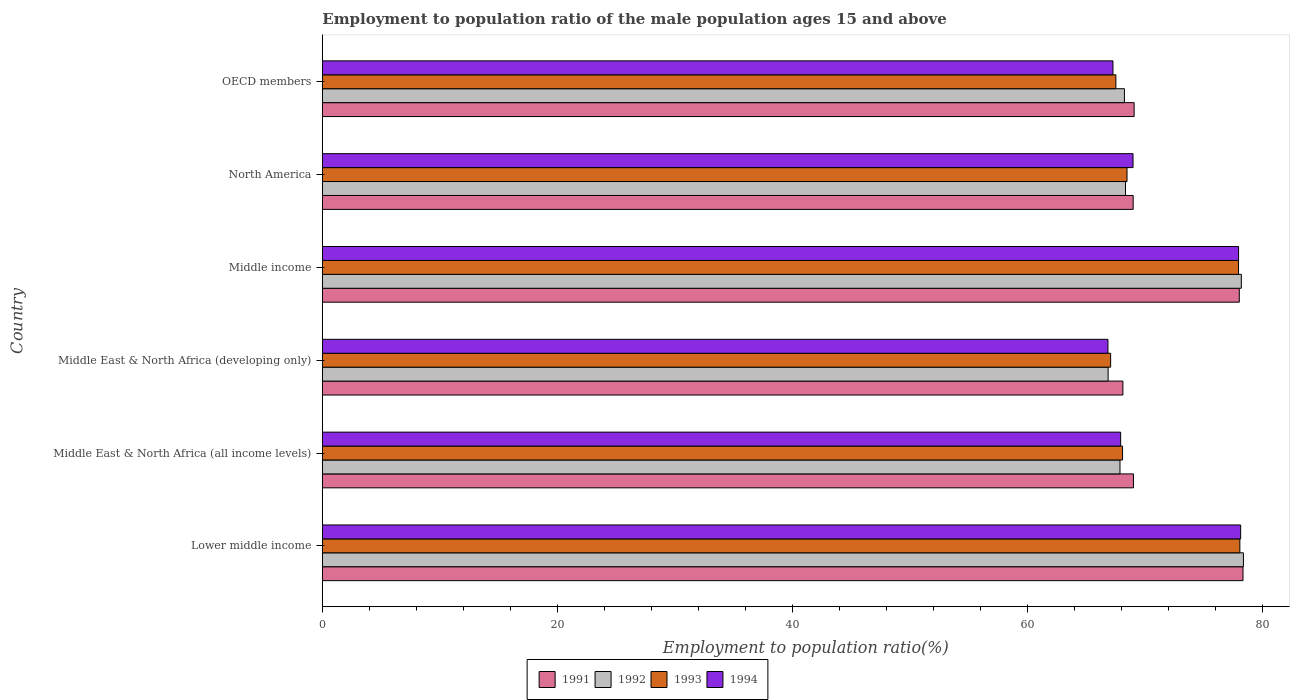How many groups of bars are there?
Offer a very short reply. 6. Are the number of bars per tick equal to the number of legend labels?
Your answer should be very brief. Yes. How many bars are there on the 3rd tick from the top?
Provide a succinct answer. 4. What is the label of the 6th group of bars from the top?
Keep it short and to the point. Lower middle income. In how many cases, is the number of bars for a given country not equal to the number of legend labels?
Make the answer very short. 0. What is the employment to population ratio in 1993 in Middle East & North Africa (developing only)?
Keep it short and to the point. 67.05. Across all countries, what is the maximum employment to population ratio in 1991?
Offer a terse response. 78.3. Across all countries, what is the minimum employment to population ratio in 1992?
Make the answer very short. 66.83. In which country was the employment to population ratio in 1993 maximum?
Make the answer very short. Lower middle income. In which country was the employment to population ratio in 1993 minimum?
Your answer should be very brief. Middle East & North Africa (developing only). What is the total employment to population ratio in 1992 in the graph?
Provide a succinct answer. 427.71. What is the difference between the employment to population ratio in 1993 in Middle East & North Africa (all income levels) and that in Middle income?
Ensure brevity in your answer.  -9.87. What is the difference between the employment to population ratio in 1994 in Middle income and the employment to population ratio in 1992 in North America?
Provide a succinct answer. 9.62. What is the average employment to population ratio in 1992 per country?
Your response must be concise. 71.28. What is the difference between the employment to population ratio in 1992 and employment to population ratio in 1993 in Middle income?
Keep it short and to the point. 0.24. In how many countries, is the employment to population ratio in 1994 greater than 68 %?
Your answer should be compact. 3. What is the ratio of the employment to population ratio in 1991 in Middle income to that in OECD members?
Keep it short and to the point. 1.13. What is the difference between the highest and the second highest employment to population ratio in 1992?
Provide a short and direct response. 0.18. What is the difference between the highest and the lowest employment to population ratio in 1992?
Make the answer very short. 11.51. In how many countries, is the employment to population ratio in 1992 greater than the average employment to population ratio in 1992 taken over all countries?
Your answer should be compact. 2. Is the sum of the employment to population ratio in 1993 in Middle income and North America greater than the maximum employment to population ratio in 1991 across all countries?
Give a very brief answer. Yes. Is it the case that in every country, the sum of the employment to population ratio in 1994 and employment to population ratio in 1992 is greater than the sum of employment to population ratio in 1993 and employment to population ratio in 1991?
Offer a terse response. No. What does the 4th bar from the bottom in Middle East & North Africa (all income levels) represents?
Your answer should be very brief. 1994. Is it the case that in every country, the sum of the employment to population ratio in 1994 and employment to population ratio in 1991 is greater than the employment to population ratio in 1993?
Offer a terse response. Yes. How many bars are there?
Your answer should be very brief. 24. Are all the bars in the graph horizontal?
Offer a terse response. Yes. How many countries are there in the graph?
Provide a short and direct response. 6. What is the difference between two consecutive major ticks on the X-axis?
Give a very brief answer. 20. Does the graph contain any zero values?
Offer a very short reply. No. Does the graph contain grids?
Offer a terse response. No. Where does the legend appear in the graph?
Offer a terse response. Bottom center. How are the legend labels stacked?
Ensure brevity in your answer.  Horizontal. What is the title of the graph?
Offer a very short reply. Employment to population ratio of the male population ages 15 and above. What is the label or title of the X-axis?
Provide a succinct answer. Employment to population ratio(%). What is the Employment to population ratio(%) of 1991 in Lower middle income?
Make the answer very short. 78.3. What is the Employment to population ratio(%) of 1992 in Lower middle income?
Offer a very short reply. 78.34. What is the Employment to population ratio(%) of 1993 in Lower middle income?
Make the answer very short. 78.04. What is the Employment to population ratio(%) of 1994 in Lower middle income?
Make the answer very short. 78.11. What is the Employment to population ratio(%) of 1991 in Middle East & North Africa (all income levels)?
Your answer should be very brief. 68.99. What is the Employment to population ratio(%) of 1992 in Middle East & North Africa (all income levels)?
Make the answer very short. 67.84. What is the Employment to population ratio(%) of 1993 in Middle East & North Africa (all income levels)?
Make the answer very short. 68.06. What is the Employment to population ratio(%) of 1994 in Middle East & North Africa (all income levels)?
Ensure brevity in your answer.  67.9. What is the Employment to population ratio(%) of 1991 in Middle East & North Africa (developing only)?
Give a very brief answer. 68.09. What is the Employment to population ratio(%) in 1992 in Middle East & North Africa (developing only)?
Your response must be concise. 66.83. What is the Employment to population ratio(%) in 1993 in Middle East & North Africa (developing only)?
Keep it short and to the point. 67.05. What is the Employment to population ratio(%) of 1994 in Middle East & North Africa (developing only)?
Give a very brief answer. 66.82. What is the Employment to population ratio(%) of 1991 in Middle income?
Offer a very short reply. 77.99. What is the Employment to population ratio(%) in 1992 in Middle income?
Make the answer very short. 78.16. What is the Employment to population ratio(%) in 1993 in Middle income?
Your answer should be compact. 77.93. What is the Employment to population ratio(%) of 1994 in Middle income?
Provide a succinct answer. 77.93. What is the Employment to population ratio(%) of 1991 in North America?
Make the answer very short. 68.96. What is the Employment to population ratio(%) of 1992 in North America?
Make the answer very short. 68.31. What is the Employment to population ratio(%) in 1993 in North America?
Your answer should be very brief. 68.44. What is the Employment to population ratio(%) in 1994 in North America?
Provide a succinct answer. 68.95. What is the Employment to population ratio(%) in 1991 in OECD members?
Ensure brevity in your answer.  69.04. What is the Employment to population ratio(%) in 1992 in OECD members?
Provide a short and direct response. 68.22. What is the Employment to population ratio(%) of 1993 in OECD members?
Provide a succinct answer. 67.49. What is the Employment to population ratio(%) in 1994 in OECD members?
Your response must be concise. 67.24. Across all countries, what is the maximum Employment to population ratio(%) of 1991?
Your response must be concise. 78.3. Across all countries, what is the maximum Employment to population ratio(%) in 1992?
Offer a very short reply. 78.34. Across all countries, what is the maximum Employment to population ratio(%) in 1993?
Make the answer very short. 78.04. Across all countries, what is the maximum Employment to population ratio(%) of 1994?
Make the answer very short. 78.11. Across all countries, what is the minimum Employment to population ratio(%) of 1991?
Make the answer very short. 68.09. Across all countries, what is the minimum Employment to population ratio(%) in 1992?
Your answer should be compact. 66.83. Across all countries, what is the minimum Employment to population ratio(%) in 1993?
Your response must be concise. 67.05. Across all countries, what is the minimum Employment to population ratio(%) in 1994?
Your answer should be compact. 66.82. What is the total Employment to population ratio(%) of 1991 in the graph?
Offer a terse response. 431.38. What is the total Employment to population ratio(%) of 1992 in the graph?
Give a very brief answer. 427.71. What is the total Employment to population ratio(%) of 1993 in the graph?
Provide a short and direct response. 427. What is the total Employment to population ratio(%) of 1994 in the graph?
Give a very brief answer. 426.95. What is the difference between the Employment to population ratio(%) of 1991 in Lower middle income and that in Middle East & North Africa (all income levels)?
Provide a succinct answer. 9.32. What is the difference between the Employment to population ratio(%) of 1992 in Lower middle income and that in Middle East & North Africa (all income levels)?
Keep it short and to the point. 10.5. What is the difference between the Employment to population ratio(%) in 1993 in Lower middle income and that in Middle East & North Africa (all income levels)?
Provide a short and direct response. 9.98. What is the difference between the Employment to population ratio(%) of 1994 in Lower middle income and that in Middle East & North Africa (all income levels)?
Offer a very short reply. 10.21. What is the difference between the Employment to population ratio(%) of 1991 in Lower middle income and that in Middle East & North Africa (developing only)?
Keep it short and to the point. 10.21. What is the difference between the Employment to population ratio(%) in 1992 in Lower middle income and that in Middle East & North Africa (developing only)?
Your response must be concise. 11.51. What is the difference between the Employment to population ratio(%) of 1993 in Lower middle income and that in Middle East & North Africa (developing only)?
Give a very brief answer. 10.99. What is the difference between the Employment to population ratio(%) in 1994 in Lower middle income and that in Middle East & North Africa (developing only)?
Provide a short and direct response. 11.29. What is the difference between the Employment to population ratio(%) in 1991 in Lower middle income and that in Middle income?
Offer a very short reply. 0.31. What is the difference between the Employment to population ratio(%) of 1992 in Lower middle income and that in Middle income?
Ensure brevity in your answer.  0.18. What is the difference between the Employment to population ratio(%) in 1993 in Lower middle income and that in Middle income?
Your answer should be very brief. 0.11. What is the difference between the Employment to population ratio(%) of 1994 in Lower middle income and that in Middle income?
Your answer should be very brief. 0.18. What is the difference between the Employment to population ratio(%) of 1991 in Lower middle income and that in North America?
Offer a very short reply. 9.34. What is the difference between the Employment to population ratio(%) in 1992 in Lower middle income and that in North America?
Provide a short and direct response. 10.03. What is the difference between the Employment to population ratio(%) of 1993 in Lower middle income and that in North America?
Your answer should be very brief. 9.6. What is the difference between the Employment to population ratio(%) in 1994 in Lower middle income and that in North America?
Keep it short and to the point. 9.15. What is the difference between the Employment to population ratio(%) in 1991 in Lower middle income and that in OECD members?
Your response must be concise. 9.26. What is the difference between the Employment to population ratio(%) of 1992 in Lower middle income and that in OECD members?
Offer a very short reply. 10.12. What is the difference between the Employment to population ratio(%) in 1993 in Lower middle income and that in OECD members?
Make the answer very short. 10.55. What is the difference between the Employment to population ratio(%) of 1994 in Lower middle income and that in OECD members?
Ensure brevity in your answer.  10.86. What is the difference between the Employment to population ratio(%) in 1991 in Middle East & North Africa (all income levels) and that in Middle East & North Africa (developing only)?
Your response must be concise. 0.9. What is the difference between the Employment to population ratio(%) of 1992 in Middle East & North Africa (all income levels) and that in Middle East & North Africa (developing only)?
Your response must be concise. 1.01. What is the difference between the Employment to population ratio(%) of 1993 in Middle East & North Africa (all income levels) and that in Middle East & North Africa (developing only)?
Your answer should be compact. 1.01. What is the difference between the Employment to population ratio(%) of 1994 in Middle East & North Africa (all income levels) and that in Middle East & North Africa (developing only)?
Provide a short and direct response. 1.08. What is the difference between the Employment to population ratio(%) of 1991 in Middle East & North Africa (all income levels) and that in Middle income?
Offer a terse response. -9. What is the difference between the Employment to population ratio(%) in 1992 in Middle East & North Africa (all income levels) and that in Middle income?
Provide a succinct answer. -10.32. What is the difference between the Employment to population ratio(%) in 1993 in Middle East & North Africa (all income levels) and that in Middle income?
Provide a short and direct response. -9.87. What is the difference between the Employment to population ratio(%) of 1994 in Middle East & North Africa (all income levels) and that in Middle income?
Offer a terse response. -10.03. What is the difference between the Employment to population ratio(%) in 1991 in Middle East & North Africa (all income levels) and that in North America?
Your answer should be compact. 0.02. What is the difference between the Employment to population ratio(%) of 1992 in Middle East & North Africa (all income levels) and that in North America?
Your answer should be compact. -0.47. What is the difference between the Employment to population ratio(%) of 1993 in Middle East & North Africa (all income levels) and that in North America?
Offer a very short reply. -0.38. What is the difference between the Employment to population ratio(%) in 1994 in Middle East & North Africa (all income levels) and that in North America?
Your answer should be very brief. -1.05. What is the difference between the Employment to population ratio(%) in 1991 in Middle East & North Africa (all income levels) and that in OECD members?
Keep it short and to the point. -0.06. What is the difference between the Employment to population ratio(%) of 1992 in Middle East & North Africa (all income levels) and that in OECD members?
Provide a succinct answer. -0.38. What is the difference between the Employment to population ratio(%) of 1993 in Middle East & North Africa (all income levels) and that in OECD members?
Keep it short and to the point. 0.57. What is the difference between the Employment to population ratio(%) in 1994 in Middle East & North Africa (all income levels) and that in OECD members?
Keep it short and to the point. 0.65. What is the difference between the Employment to population ratio(%) of 1992 in Middle East & North Africa (developing only) and that in Middle income?
Make the answer very short. -11.33. What is the difference between the Employment to population ratio(%) of 1993 in Middle East & North Africa (developing only) and that in Middle income?
Your answer should be compact. -10.88. What is the difference between the Employment to population ratio(%) of 1994 in Middle East & North Africa (developing only) and that in Middle income?
Keep it short and to the point. -11.11. What is the difference between the Employment to population ratio(%) in 1991 in Middle East & North Africa (developing only) and that in North America?
Provide a short and direct response. -0.87. What is the difference between the Employment to population ratio(%) in 1992 in Middle East & North Africa (developing only) and that in North America?
Your answer should be compact. -1.48. What is the difference between the Employment to population ratio(%) of 1993 in Middle East & North Africa (developing only) and that in North America?
Your response must be concise. -1.39. What is the difference between the Employment to population ratio(%) of 1994 in Middle East & North Africa (developing only) and that in North America?
Ensure brevity in your answer.  -2.13. What is the difference between the Employment to population ratio(%) in 1991 in Middle East & North Africa (developing only) and that in OECD members?
Your answer should be compact. -0.95. What is the difference between the Employment to population ratio(%) of 1992 in Middle East & North Africa (developing only) and that in OECD members?
Your answer should be compact. -1.39. What is the difference between the Employment to population ratio(%) in 1993 in Middle East & North Africa (developing only) and that in OECD members?
Offer a terse response. -0.44. What is the difference between the Employment to population ratio(%) of 1994 in Middle East & North Africa (developing only) and that in OECD members?
Provide a succinct answer. -0.43. What is the difference between the Employment to population ratio(%) in 1991 in Middle income and that in North America?
Give a very brief answer. 9.03. What is the difference between the Employment to population ratio(%) in 1992 in Middle income and that in North America?
Offer a terse response. 9.85. What is the difference between the Employment to population ratio(%) of 1993 in Middle income and that in North America?
Your answer should be very brief. 9.49. What is the difference between the Employment to population ratio(%) of 1994 in Middle income and that in North America?
Your response must be concise. 8.98. What is the difference between the Employment to population ratio(%) in 1991 in Middle income and that in OECD members?
Your answer should be compact. 8.95. What is the difference between the Employment to population ratio(%) in 1992 in Middle income and that in OECD members?
Offer a very short reply. 9.94. What is the difference between the Employment to population ratio(%) of 1993 in Middle income and that in OECD members?
Your answer should be compact. 10.43. What is the difference between the Employment to population ratio(%) of 1994 in Middle income and that in OECD members?
Provide a succinct answer. 10.68. What is the difference between the Employment to population ratio(%) in 1991 in North America and that in OECD members?
Your answer should be compact. -0.08. What is the difference between the Employment to population ratio(%) of 1992 in North America and that in OECD members?
Provide a short and direct response. 0.09. What is the difference between the Employment to population ratio(%) in 1993 in North America and that in OECD members?
Offer a very short reply. 0.95. What is the difference between the Employment to population ratio(%) in 1994 in North America and that in OECD members?
Give a very brief answer. 1.71. What is the difference between the Employment to population ratio(%) in 1991 in Lower middle income and the Employment to population ratio(%) in 1992 in Middle East & North Africa (all income levels)?
Give a very brief answer. 10.46. What is the difference between the Employment to population ratio(%) in 1991 in Lower middle income and the Employment to population ratio(%) in 1993 in Middle East & North Africa (all income levels)?
Make the answer very short. 10.24. What is the difference between the Employment to population ratio(%) in 1991 in Lower middle income and the Employment to population ratio(%) in 1994 in Middle East & North Africa (all income levels)?
Ensure brevity in your answer.  10.41. What is the difference between the Employment to population ratio(%) in 1992 in Lower middle income and the Employment to population ratio(%) in 1993 in Middle East & North Africa (all income levels)?
Your answer should be compact. 10.28. What is the difference between the Employment to population ratio(%) of 1992 in Lower middle income and the Employment to population ratio(%) of 1994 in Middle East & North Africa (all income levels)?
Provide a succinct answer. 10.44. What is the difference between the Employment to population ratio(%) of 1993 in Lower middle income and the Employment to population ratio(%) of 1994 in Middle East & North Africa (all income levels)?
Your answer should be compact. 10.14. What is the difference between the Employment to population ratio(%) in 1991 in Lower middle income and the Employment to population ratio(%) in 1992 in Middle East & North Africa (developing only)?
Provide a short and direct response. 11.47. What is the difference between the Employment to population ratio(%) in 1991 in Lower middle income and the Employment to population ratio(%) in 1993 in Middle East & North Africa (developing only)?
Your answer should be very brief. 11.26. What is the difference between the Employment to population ratio(%) in 1991 in Lower middle income and the Employment to population ratio(%) in 1994 in Middle East & North Africa (developing only)?
Provide a succinct answer. 11.49. What is the difference between the Employment to population ratio(%) of 1992 in Lower middle income and the Employment to population ratio(%) of 1993 in Middle East & North Africa (developing only)?
Give a very brief answer. 11.29. What is the difference between the Employment to population ratio(%) of 1992 in Lower middle income and the Employment to population ratio(%) of 1994 in Middle East & North Africa (developing only)?
Your answer should be very brief. 11.52. What is the difference between the Employment to population ratio(%) of 1993 in Lower middle income and the Employment to population ratio(%) of 1994 in Middle East & North Africa (developing only)?
Provide a succinct answer. 11.22. What is the difference between the Employment to population ratio(%) in 1991 in Lower middle income and the Employment to population ratio(%) in 1992 in Middle income?
Keep it short and to the point. 0.14. What is the difference between the Employment to population ratio(%) of 1991 in Lower middle income and the Employment to population ratio(%) of 1993 in Middle income?
Offer a very short reply. 0.38. What is the difference between the Employment to population ratio(%) in 1991 in Lower middle income and the Employment to population ratio(%) in 1994 in Middle income?
Your answer should be very brief. 0.38. What is the difference between the Employment to population ratio(%) of 1992 in Lower middle income and the Employment to population ratio(%) of 1993 in Middle income?
Your answer should be compact. 0.42. What is the difference between the Employment to population ratio(%) of 1992 in Lower middle income and the Employment to population ratio(%) of 1994 in Middle income?
Your response must be concise. 0.41. What is the difference between the Employment to population ratio(%) in 1993 in Lower middle income and the Employment to population ratio(%) in 1994 in Middle income?
Give a very brief answer. 0.11. What is the difference between the Employment to population ratio(%) in 1991 in Lower middle income and the Employment to population ratio(%) in 1992 in North America?
Provide a short and direct response. 9.99. What is the difference between the Employment to population ratio(%) of 1991 in Lower middle income and the Employment to population ratio(%) of 1993 in North America?
Your response must be concise. 9.86. What is the difference between the Employment to population ratio(%) in 1991 in Lower middle income and the Employment to population ratio(%) in 1994 in North America?
Make the answer very short. 9.35. What is the difference between the Employment to population ratio(%) of 1992 in Lower middle income and the Employment to population ratio(%) of 1993 in North America?
Give a very brief answer. 9.9. What is the difference between the Employment to population ratio(%) in 1992 in Lower middle income and the Employment to population ratio(%) in 1994 in North America?
Your answer should be very brief. 9.39. What is the difference between the Employment to population ratio(%) in 1993 in Lower middle income and the Employment to population ratio(%) in 1994 in North America?
Give a very brief answer. 9.09. What is the difference between the Employment to population ratio(%) of 1991 in Lower middle income and the Employment to population ratio(%) of 1992 in OECD members?
Ensure brevity in your answer.  10.09. What is the difference between the Employment to population ratio(%) in 1991 in Lower middle income and the Employment to population ratio(%) in 1993 in OECD members?
Offer a very short reply. 10.81. What is the difference between the Employment to population ratio(%) in 1991 in Lower middle income and the Employment to population ratio(%) in 1994 in OECD members?
Keep it short and to the point. 11.06. What is the difference between the Employment to population ratio(%) of 1992 in Lower middle income and the Employment to population ratio(%) of 1993 in OECD members?
Provide a succinct answer. 10.85. What is the difference between the Employment to population ratio(%) of 1992 in Lower middle income and the Employment to population ratio(%) of 1994 in OECD members?
Provide a succinct answer. 11.1. What is the difference between the Employment to population ratio(%) of 1993 in Lower middle income and the Employment to population ratio(%) of 1994 in OECD members?
Your response must be concise. 10.79. What is the difference between the Employment to population ratio(%) of 1991 in Middle East & North Africa (all income levels) and the Employment to population ratio(%) of 1992 in Middle East & North Africa (developing only)?
Offer a very short reply. 2.15. What is the difference between the Employment to population ratio(%) in 1991 in Middle East & North Africa (all income levels) and the Employment to population ratio(%) in 1993 in Middle East & North Africa (developing only)?
Provide a short and direct response. 1.94. What is the difference between the Employment to population ratio(%) of 1991 in Middle East & North Africa (all income levels) and the Employment to population ratio(%) of 1994 in Middle East & North Africa (developing only)?
Your answer should be compact. 2.17. What is the difference between the Employment to population ratio(%) in 1992 in Middle East & North Africa (all income levels) and the Employment to population ratio(%) in 1993 in Middle East & North Africa (developing only)?
Provide a succinct answer. 0.79. What is the difference between the Employment to population ratio(%) of 1992 in Middle East & North Africa (all income levels) and the Employment to population ratio(%) of 1994 in Middle East & North Africa (developing only)?
Make the answer very short. 1.02. What is the difference between the Employment to population ratio(%) of 1993 in Middle East & North Africa (all income levels) and the Employment to population ratio(%) of 1994 in Middle East & North Africa (developing only)?
Keep it short and to the point. 1.24. What is the difference between the Employment to population ratio(%) in 1991 in Middle East & North Africa (all income levels) and the Employment to population ratio(%) in 1992 in Middle income?
Offer a terse response. -9.18. What is the difference between the Employment to population ratio(%) in 1991 in Middle East & North Africa (all income levels) and the Employment to population ratio(%) in 1993 in Middle income?
Make the answer very short. -8.94. What is the difference between the Employment to population ratio(%) of 1991 in Middle East & North Africa (all income levels) and the Employment to population ratio(%) of 1994 in Middle income?
Make the answer very short. -8.94. What is the difference between the Employment to population ratio(%) of 1992 in Middle East & North Africa (all income levels) and the Employment to population ratio(%) of 1993 in Middle income?
Provide a short and direct response. -10.08. What is the difference between the Employment to population ratio(%) of 1992 in Middle East & North Africa (all income levels) and the Employment to population ratio(%) of 1994 in Middle income?
Provide a short and direct response. -10.09. What is the difference between the Employment to population ratio(%) of 1993 in Middle East & North Africa (all income levels) and the Employment to population ratio(%) of 1994 in Middle income?
Your answer should be compact. -9.87. What is the difference between the Employment to population ratio(%) in 1991 in Middle East & North Africa (all income levels) and the Employment to population ratio(%) in 1992 in North America?
Your answer should be very brief. 0.68. What is the difference between the Employment to population ratio(%) in 1991 in Middle East & North Africa (all income levels) and the Employment to population ratio(%) in 1993 in North America?
Provide a succinct answer. 0.55. What is the difference between the Employment to population ratio(%) in 1991 in Middle East & North Africa (all income levels) and the Employment to population ratio(%) in 1994 in North America?
Offer a terse response. 0.03. What is the difference between the Employment to population ratio(%) of 1992 in Middle East & North Africa (all income levels) and the Employment to population ratio(%) of 1993 in North America?
Your answer should be compact. -0.6. What is the difference between the Employment to population ratio(%) of 1992 in Middle East & North Africa (all income levels) and the Employment to population ratio(%) of 1994 in North America?
Offer a very short reply. -1.11. What is the difference between the Employment to population ratio(%) in 1993 in Middle East & North Africa (all income levels) and the Employment to population ratio(%) in 1994 in North America?
Give a very brief answer. -0.89. What is the difference between the Employment to population ratio(%) of 1991 in Middle East & North Africa (all income levels) and the Employment to population ratio(%) of 1992 in OECD members?
Offer a terse response. 0.77. What is the difference between the Employment to population ratio(%) of 1991 in Middle East & North Africa (all income levels) and the Employment to population ratio(%) of 1993 in OECD members?
Provide a succinct answer. 1.49. What is the difference between the Employment to population ratio(%) of 1991 in Middle East & North Africa (all income levels) and the Employment to population ratio(%) of 1994 in OECD members?
Offer a terse response. 1.74. What is the difference between the Employment to population ratio(%) of 1992 in Middle East & North Africa (all income levels) and the Employment to population ratio(%) of 1993 in OECD members?
Your response must be concise. 0.35. What is the difference between the Employment to population ratio(%) in 1992 in Middle East & North Africa (all income levels) and the Employment to population ratio(%) in 1994 in OECD members?
Offer a terse response. 0.6. What is the difference between the Employment to population ratio(%) of 1993 in Middle East & North Africa (all income levels) and the Employment to population ratio(%) of 1994 in OECD members?
Provide a succinct answer. 0.81. What is the difference between the Employment to population ratio(%) in 1991 in Middle East & North Africa (developing only) and the Employment to population ratio(%) in 1992 in Middle income?
Give a very brief answer. -10.07. What is the difference between the Employment to population ratio(%) in 1991 in Middle East & North Africa (developing only) and the Employment to population ratio(%) in 1993 in Middle income?
Offer a very short reply. -9.84. What is the difference between the Employment to population ratio(%) of 1991 in Middle East & North Africa (developing only) and the Employment to population ratio(%) of 1994 in Middle income?
Give a very brief answer. -9.84. What is the difference between the Employment to population ratio(%) of 1992 in Middle East & North Africa (developing only) and the Employment to population ratio(%) of 1993 in Middle income?
Keep it short and to the point. -11.09. What is the difference between the Employment to population ratio(%) in 1992 in Middle East & North Africa (developing only) and the Employment to population ratio(%) in 1994 in Middle income?
Make the answer very short. -11.1. What is the difference between the Employment to population ratio(%) in 1993 in Middle East & North Africa (developing only) and the Employment to population ratio(%) in 1994 in Middle income?
Provide a succinct answer. -10.88. What is the difference between the Employment to population ratio(%) in 1991 in Middle East & North Africa (developing only) and the Employment to population ratio(%) in 1992 in North America?
Make the answer very short. -0.22. What is the difference between the Employment to population ratio(%) in 1991 in Middle East & North Africa (developing only) and the Employment to population ratio(%) in 1993 in North America?
Make the answer very short. -0.35. What is the difference between the Employment to population ratio(%) of 1991 in Middle East & North Africa (developing only) and the Employment to population ratio(%) of 1994 in North America?
Your answer should be very brief. -0.86. What is the difference between the Employment to population ratio(%) in 1992 in Middle East & North Africa (developing only) and the Employment to population ratio(%) in 1993 in North America?
Ensure brevity in your answer.  -1.61. What is the difference between the Employment to population ratio(%) of 1992 in Middle East & North Africa (developing only) and the Employment to population ratio(%) of 1994 in North America?
Provide a short and direct response. -2.12. What is the difference between the Employment to population ratio(%) of 1993 in Middle East & North Africa (developing only) and the Employment to population ratio(%) of 1994 in North America?
Your answer should be compact. -1.9. What is the difference between the Employment to population ratio(%) in 1991 in Middle East & North Africa (developing only) and the Employment to population ratio(%) in 1992 in OECD members?
Your response must be concise. -0.13. What is the difference between the Employment to population ratio(%) of 1991 in Middle East & North Africa (developing only) and the Employment to population ratio(%) of 1993 in OECD members?
Provide a short and direct response. 0.6. What is the difference between the Employment to population ratio(%) in 1991 in Middle East & North Africa (developing only) and the Employment to population ratio(%) in 1994 in OECD members?
Your answer should be compact. 0.84. What is the difference between the Employment to population ratio(%) in 1992 in Middle East & North Africa (developing only) and the Employment to population ratio(%) in 1993 in OECD members?
Ensure brevity in your answer.  -0.66. What is the difference between the Employment to population ratio(%) in 1992 in Middle East & North Africa (developing only) and the Employment to population ratio(%) in 1994 in OECD members?
Offer a terse response. -0.41. What is the difference between the Employment to population ratio(%) in 1993 in Middle East & North Africa (developing only) and the Employment to population ratio(%) in 1994 in OECD members?
Ensure brevity in your answer.  -0.2. What is the difference between the Employment to population ratio(%) of 1991 in Middle income and the Employment to population ratio(%) of 1992 in North America?
Ensure brevity in your answer.  9.68. What is the difference between the Employment to population ratio(%) in 1991 in Middle income and the Employment to population ratio(%) in 1993 in North America?
Provide a short and direct response. 9.55. What is the difference between the Employment to population ratio(%) in 1991 in Middle income and the Employment to population ratio(%) in 1994 in North America?
Provide a short and direct response. 9.04. What is the difference between the Employment to population ratio(%) of 1992 in Middle income and the Employment to population ratio(%) of 1993 in North America?
Make the answer very short. 9.72. What is the difference between the Employment to population ratio(%) of 1992 in Middle income and the Employment to population ratio(%) of 1994 in North America?
Offer a terse response. 9.21. What is the difference between the Employment to population ratio(%) in 1993 in Middle income and the Employment to population ratio(%) in 1994 in North America?
Make the answer very short. 8.97. What is the difference between the Employment to population ratio(%) in 1991 in Middle income and the Employment to population ratio(%) in 1992 in OECD members?
Offer a terse response. 9.77. What is the difference between the Employment to population ratio(%) in 1991 in Middle income and the Employment to population ratio(%) in 1993 in OECD members?
Your answer should be compact. 10.5. What is the difference between the Employment to population ratio(%) of 1991 in Middle income and the Employment to population ratio(%) of 1994 in OECD members?
Provide a short and direct response. 10.74. What is the difference between the Employment to population ratio(%) in 1992 in Middle income and the Employment to population ratio(%) in 1993 in OECD members?
Your response must be concise. 10.67. What is the difference between the Employment to population ratio(%) in 1992 in Middle income and the Employment to population ratio(%) in 1994 in OECD members?
Your response must be concise. 10.92. What is the difference between the Employment to population ratio(%) in 1993 in Middle income and the Employment to population ratio(%) in 1994 in OECD members?
Offer a terse response. 10.68. What is the difference between the Employment to population ratio(%) in 1991 in North America and the Employment to population ratio(%) in 1992 in OECD members?
Ensure brevity in your answer.  0.74. What is the difference between the Employment to population ratio(%) of 1991 in North America and the Employment to population ratio(%) of 1993 in OECD members?
Your answer should be very brief. 1.47. What is the difference between the Employment to population ratio(%) in 1991 in North America and the Employment to population ratio(%) in 1994 in OECD members?
Provide a short and direct response. 1.72. What is the difference between the Employment to population ratio(%) of 1992 in North America and the Employment to population ratio(%) of 1993 in OECD members?
Your response must be concise. 0.82. What is the difference between the Employment to population ratio(%) in 1992 in North America and the Employment to population ratio(%) in 1994 in OECD members?
Offer a terse response. 1.07. What is the difference between the Employment to population ratio(%) in 1993 in North America and the Employment to population ratio(%) in 1994 in OECD members?
Your answer should be very brief. 1.2. What is the average Employment to population ratio(%) of 1991 per country?
Give a very brief answer. 71.9. What is the average Employment to population ratio(%) in 1992 per country?
Provide a succinct answer. 71.28. What is the average Employment to population ratio(%) in 1993 per country?
Give a very brief answer. 71.17. What is the average Employment to population ratio(%) of 1994 per country?
Offer a terse response. 71.16. What is the difference between the Employment to population ratio(%) in 1991 and Employment to population ratio(%) in 1992 in Lower middle income?
Your answer should be compact. -0.04. What is the difference between the Employment to population ratio(%) of 1991 and Employment to population ratio(%) of 1993 in Lower middle income?
Give a very brief answer. 0.27. What is the difference between the Employment to population ratio(%) in 1991 and Employment to population ratio(%) in 1994 in Lower middle income?
Provide a succinct answer. 0.2. What is the difference between the Employment to population ratio(%) in 1992 and Employment to population ratio(%) in 1993 in Lower middle income?
Give a very brief answer. 0.3. What is the difference between the Employment to population ratio(%) in 1992 and Employment to population ratio(%) in 1994 in Lower middle income?
Offer a terse response. 0.24. What is the difference between the Employment to population ratio(%) in 1993 and Employment to population ratio(%) in 1994 in Lower middle income?
Make the answer very short. -0.07. What is the difference between the Employment to population ratio(%) in 1991 and Employment to population ratio(%) in 1992 in Middle East & North Africa (all income levels)?
Provide a short and direct response. 1.14. What is the difference between the Employment to population ratio(%) of 1991 and Employment to population ratio(%) of 1993 in Middle East & North Africa (all income levels)?
Provide a short and direct response. 0.93. What is the difference between the Employment to population ratio(%) in 1991 and Employment to population ratio(%) in 1994 in Middle East & North Africa (all income levels)?
Keep it short and to the point. 1.09. What is the difference between the Employment to population ratio(%) in 1992 and Employment to population ratio(%) in 1993 in Middle East & North Africa (all income levels)?
Make the answer very short. -0.22. What is the difference between the Employment to population ratio(%) in 1992 and Employment to population ratio(%) in 1994 in Middle East & North Africa (all income levels)?
Ensure brevity in your answer.  -0.06. What is the difference between the Employment to population ratio(%) of 1993 and Employment to population ratio(%) of 1994 in Middle East & North Africa (all income levels)?
Offer a terse response. 0.16. What is the difference between the Employment to population ratio(%) of 1991 and Employment to population ratio(%) of 1992 in Middle East & North Africa (developing only)?
Provide a succinct answer. 1.26. What is the difference between the Employment to population ratio(%) in 1991 and Employment to population ratio(%) in 1993 in Middle East & North Africa (developing only)?
Provide a succinct answer. 1.04. What is the difference between the Employment to population ratio(%) of 1991 and Employment to population ratio(%) of 1994 in Middle East & North Africa (developing only)?
Offer a terse response. 1.27. What is the difference between the Employment to population ratio(%) in 1992 and Employment to population ratio(%) in 1993 in Middle East & North Africa (developing only)?
Offer a terse response. -0.21. What is the difference between the Employment to population ratio(%) in 1992 and Employment to population ratio(%) in 1994 in Middle East & North Africa (developing only)?
Your response must be concise. 0.01. What is the difference between the Employment to population ratio(%) in 1993 and Employment to population ratio(%) in 1994 in Middle East & North Africa (developing only)?
Provide a succinct answer. 0.23. What is the difference between the Employment to population ratio(%) of 1991 and Employment to population ratio(%) of 1992 in Middle income?
Keep it short and to the point. -0.17. What is the difference between the Employment to population ratio(%) of 1991 and Employment to population ratio(%) of 1993 in Middle income?
Provide a succinct answer. 0.06. What is the difference between the Employment to population ratio(%) of 1991 and Employment to population ratio(%) of 1994 in Middle income?
Your response must be concise. 0.06. What is the difference between the Employment to population ratio(%) of 1992 and Employment to population ratio(%) of 1993 in Middle income?
Ensure brevity in your answer.  0.24. What is the difference between the Employment to population ratio(%) of 1992 and Employment to population ratio(%) of 1994 in Middle income?
Provide a short and direct response. 0.23. What is the difference between the Employment to population ratio(%) of 1993 and Employment to population ratio(%) of 1994 in Middle income?
Ensure brevity in your answer.  -0. What is the difference between the Employment to population ratio(%) in 1991 and Employment to population ratio(%) in 1992 in North America?
Offer a very short reply. 0.65. What is the difference between the Employment to population ratio(%) of 1991 and Employment to population ratio(%) of 1993 in North America?
Offer a very short reply. 0.52. What is the difference between the Employment to population ratio(%) in 1991 and Employment to population ratio(%) in 1994 in North America?
Offer a very short reply. 0.01. What is the difference between the Employment to population ratio(%) of 1992 and Employment to population ratio(%) of 1993 in North America?
Keep it short and to the point. -0.13. What is the difference between the Employment to population ratio(%) in 1992 and Employment to population ratio(%) in 1994 in North America?
Provide a short and direct response. -0.64. What is the difference between the Employment to population ratio(%) in 1993 and Employment to population ratio(%) in 1994 in North America?
Offer a very short reply. -0.51. What is the difference between the Employment to population ratio(%) in 1991 and Employment to population ratio(%) in 1992 in OECD members?
Offer a very short reply. 0.83. What is the difference between the Employment to population ratio(%) of 1991 and Employment to population ratio(%) of 1993 in OECD members?
Provide a succinct answer. 1.55. What is the difference between the Employment to population ratio(%) in 1991 and Employment to population ratio(%) in 1994 in OECD members?
Give a very brief answer. 1.8. What is the difference between the Employment to population ratio(%) of 1992 and Employment to population ratio(%) of 1993 in OECD members?
Make the answer very short. 0.73. What is the difference between the Employment to population ratio(%) in 1992 and Employment to population ratio(%) in 1994 in OECD members?
Give a very brief answer. 0.97. What is the difference between the Employment to population ratio(%) of 1993 and Employment to population ratio(%) of 1994 in OECD members?
Make the answer very short. 0.25. What is the ratio of the Employment to population ratio(%) of 1991 in Lower middle income to that in Middle East & North Africa (all income levels)?
Your answer should be very brief. 1.14. What is the ratio of the Employment to population ratio(%) of 1992 in Lower middle income to that in Middle East & North Africa (all income levels)?
Your answer should be very brief. 1.15. What is the ratio of the Employment to population ratio(%) of 1993 in Lower middle income to that in Middle East & North Africa (all income levels)?
Offer a very short reply. 1.15. What is the ratio of the Employment to population ratio(%) of 1994 in Lower middle income to that in Middle East & North Africa (all income levels)?
Give a very brief answer. 1.15. What is the ratio of the Employment to population ratio(%) of 1991 in Lower middle income to that in Middle East & North Africa (developing only)?
Your response must be concise. 1.15. What is the ratio of the Employment to population ratio(%) in 1992 in Lower middle income to that in Middle East & North Africa (developing only)?
Keep it short and to the point. 1.17. What is the ratio of the Employment to population ratio(%) of 1993 in Lower middle income to that in Middle East & North Africa (developing only)?
Provide a succinct answer. 1.16. What is the ratio of the Employment to population ratio(%) in 1994 in Lower middle income to that in Middle East & North Africa (developing only)?
Provide a short and direct response. 1.17. What is the ratio of the Employment to population ratio(%) in 1992 in Lower middle income to that in Middle income?
Ensure brevity in your answer.  1. What is the ratio of the Employment to population ratio(%) of 1994 in Lower middle income to that in Middle income?
Ensure brevity in your answer.  1. What is the ratio of the Employment to population ratio(%) of 1991 in Lower middle income to that in North America?
Your response must be concise. 1.14. What is the ratio of the Employment to population ratio(%) in 1992 in Lower middle income to that in North America?
Your answer should be very brief. 1.15. What is the ratio of the Employment to population ratio(%) in 1993 in Lower middle income to that in North America?
Give a very brief answer. 1.14. What is the ratio of the Employment to population ratio(%) of 1994 in Lower middle income to that in North America?
Your answer should be very brief. 1.13. What is the ratio of the Employment to population ratio(%) in 1991 in Lower middle income to that in OECD members?
Provide a succinct answer. 1.13. What is the ratio of the Employment to population ratio(%) in 1992 in Lower middle income to that in OECD members?
Your answer should be very brief. 1.15. What is the ratio of the Employment to population ratio(%) in 1993 in Lower middle income to that in OECD members?
Your response must be concise. 1.16. What is the ratio of the Employment to population ratio(%) in 1994 in Lower middle income to that in OECD members?
Make the answer very short. 1.16. What is the ratio of the Employment to population ratio(%) in 1991 in Middle East & North Africa (all income levels) to that in Middle East & North Africa (developing only)?
Offer a terse response. 1.01. What is the ratio of the Employment to population ratio(%) of 1992 in Middle East & North Africa (all income levels) to that in Middle East & North Africa (developing only)?
Provide a succinct answer. 1.02. What is the ratio of the Employment to population ratio(%) of 1993 in Middle East & North Africa (all income levels) to that in Middle East & North Africa (developing only)?
Offer a terse response. 1.02. What is the ratio of the Employment to population ratio(%) in 1994 in Middle East & North Africa (all income levels) to that in Middle East & North Africa (developing only)?
Your answer should be very brief. 1.02. What is the ratio of the Employment to population ratio(%) in 1991 in Middle East & North Africa (all income levels) to that in Middle income?
Provide a succinct answer. 0.88. What is the ratio of the Employment to population ratio(%) of 1992 in Middle East & North Africa (all income levels) to that in Middle income?
Provide a short and direct response. 0.87. What is the ratio of the Employment to population ratio(%) of 1993 in Middle East & North Africa (all income levels) to that in Middle income?
Offer a terse response. 0.87. What is the ratio of the Employment to population ratio(%) of 1994 in Middle East & North Africa (all income levels) to that in Middle income?
Ensure brevity in your answer.  0.87. What is the ratio of the Employment to population ratio(%) of 1991 in Middle East & North Africa (all income levels) to that in North America?
Your answer should be very brief. 1. What is the ratio of the Employment to population ratio(%) of 1994 in Middle East & North Africa (all income levels) to that in North America?
Your answer should be compact. 0.98. What is the ratio of the Employment to population ratio(%) in 1991 in Middle East & North Africa (all income levels) to that in OECD members?
Offer a very short reply. 1. What is the ratio of the Employment to population ratio(%) in 1992 in Middle East & North Africa (all income levels) to that in OECD members?
Provide a short and direct response. 0.99. What is the ratio of the Employment to population ratio(%) in 1993 in Middle East & North Africa (all income levels) to that in OECD members?
Offer a terse response. 1.01. What is the ratio of the Employment to population ratio(%) of 1994 in Middle East & North Africa (all income levels) to that in OECD members?
Provide a short and direct response. 1.01. What is the ratio of the Employment to population ratio(%) of 1991 in Middle East & North Africa (developing only) to that in Middle income?
Offer a very short reply. 0.87. What is the ratio of the Employment to population ratio(%) of 1992 in Middle East & North Africa (developing only) to that in Middle income?
Your answer should be very brief. 0.85. What is the ratio of the Employment to population ratio(%) of 1993 in Middle East & North Africa (developing only) to that in Middle income?
Provide a short and direct response. 0.86. What is the ratio of the Employment to population ratio(%) in 1994 in Middle East & North Africa (developing only) to that in Middle income?
Your answer should be compact. 0.86. What is the ratio of the Employment to population ratio(%) of 1991 in Middle East & North Africa (developing only) to that in North America?
Your answer should be very brief. 0.99. What is the ratio of the Employment to population ratio(%) of 1992 in Middle East & North Africa (developing only) to that in North America?
Keep it short and to the point. 0.98. What is the ratio of the Employment to population ratio(%) of 1993 in Middle East & North Africa (developing only) to that in North America?
Ensure brevity in your answer.  0.98. What is the ratio of the Employment to population ratio(%) in 1994 in Middle East & North Africa (developing only) to that in North America?
Give a very brief answer. 0.97. What is the ratio of the Employment to population ratio(%) of 1991 in Middle East & North Africa (developing only) to that in OECD members?
Give a very brief answer. 0.99. What is the ratio of the Employment to population ratio(%) of 1992 in Middle East & North Africa (developing only) to that in OECD members?
Your answer should be compact. 0.98. What is the ratio of the Employment to population ratio(%) of 1991 in Middle income to that in North America?
Offer a very short reply. 1.13. What is the ratio of the Employment to population ratio(%) in 1992 in Middle income to that in North America?
Provide a succinct answer. 1.14. What is the ratio of the Employment to population ratio(%) of 1993 in Middle income to that in North America?
Give a very brief answer. 1.14. What is the ratio of the Employment to population ratio(%) of 1994 in Middle income to that in North America?
Provide a short and direct response. 1.13. What is the ratio of the Employment to population ratio(%) in 1991 in Middle income to that in OECD members?
Offer a terse response. 1.13. What is the ratio of the Employment to population ratio(%) of 1992 in Middle income to that in OECD members?
Provide a succinct answer. 1.15. What is the ratio of the Employment to population ratio(%) in 1993 in Middle income to that in OECD members?
Provide a short and direct response. 1.15. What is the ratio of the Employment to population ratio(%) in 1994 in Middle income to that in OECD members?
Ensure brevity in your answer.  1.16. What is the ratio of the Employment to population ratio(%) in 1991 in North America to that in OECD members?
Offer a very short reply. 1. What is the ratio of the Employment to population ratio(%) in 1993 in North America to that in OECD members?
Keep it short and to the point. 1.01. What is the ratio of the Employment to population ratio(%) of 1994 in North America to that in OECD members?
Your answer should be very brief. 1.03. What is the difference between the highest and the second highest Employment to population ratio(%) in 1991?
Make the answer very short. 0.31. What is the difference between the highest and the second highest Employment to population ratio(%) of 1992?
Offer a terse response. 0.18. What is the difference between the highest and the second highest Employment to population ratio(%) of 1993?
Your answer should be very brief. 0.11. What is the difference between the highest and the second highest Employment to population ratio(%) of 1994?
Provide a short and direct response. 0.18. What is the difference between the highest and the lowest Employment to population ratio(%) in 1991?
Your answer should be very brief. 10.21. What is the difference between the highest and the lowest Employment to population ratio(%) in 1992?
Your answer should be compact. 11.51. What is the difference between the highest and the lowest Employment to population ratio(%) of 1993?
Give a very brief answer. 10.99. What is the difference between the highest and the lowest Employment to population ratio(%) of 1994?
Provide a short and direct response. 11.29. 